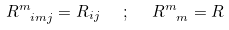Convert formula to latex. <formula><loc_0><loc_0><loc_500><loc_500>R ^ { m } _ { \ i m j } = R _ { i j } \ \ ; \ \ R ^ { m } _ { \ m } = R</formula> 